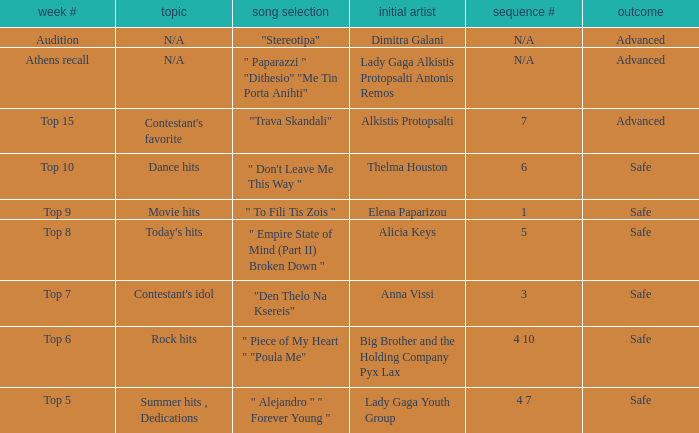Which song was chosen during the audition week? "Stereotipa". 